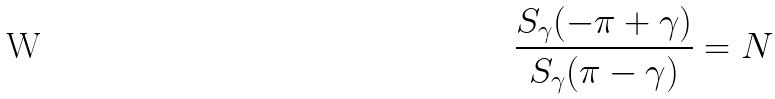Convert formula to latex. <formula><loc_0><loc_0><loc_500><loc_500>\frac { S _ { \gamma } ( - \pi + \gamma ) } { S _ { \gamma } ( \pi - \gamma ) } = N</formula> 